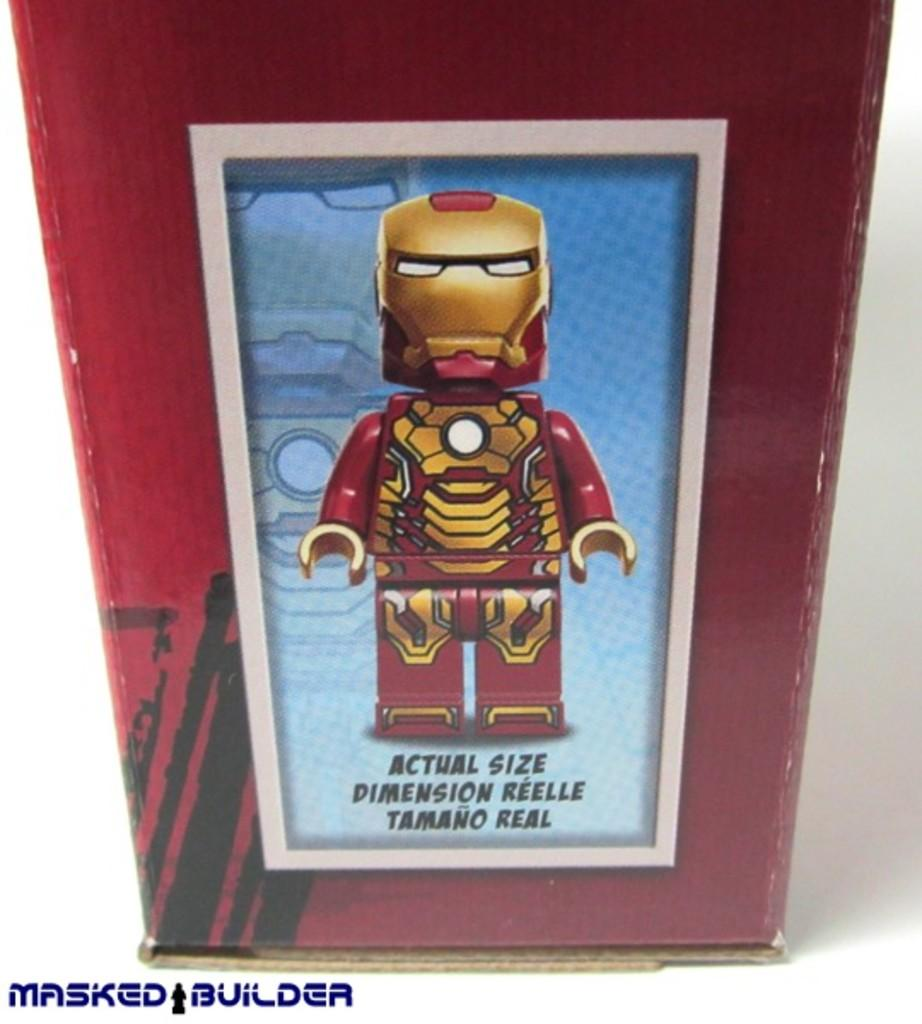Provide a one-sentence caption for the provided image. An Actual Size lego is shown in the box. 